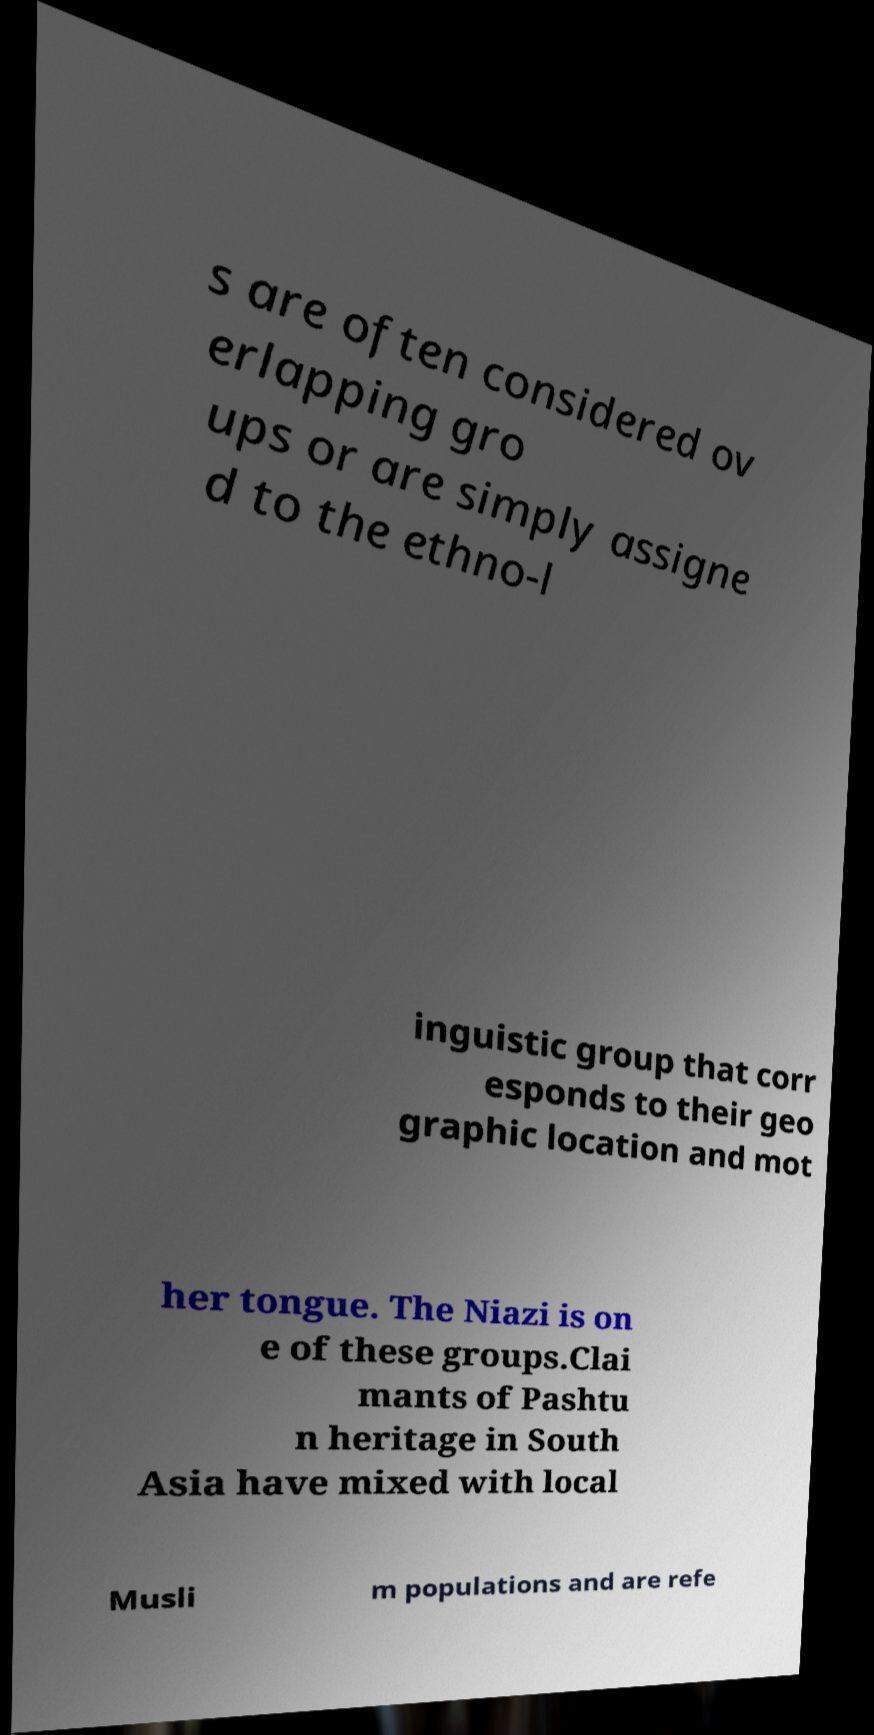Could you assist in decoding the text presented in this image and type it out clearly? s are often considered ov erlapping gro ups or are simply assigne d to the ethno-l inguistic group that corr esponds to their geo graphic location and mot her tongue. The Niazi is on e of these groups.Clai mants of Pashtu n heritage in South Asia have mixed with local Musli m populations and are refe 